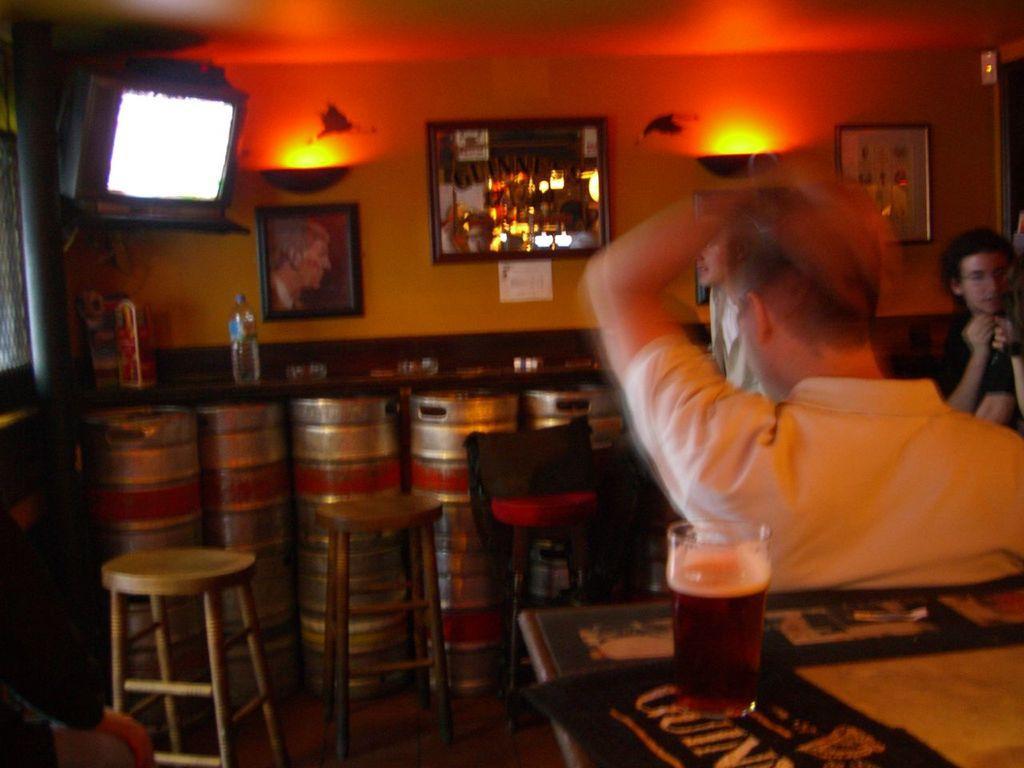Please provide a concise description of this image. This picture is a man and their some bottle kept on the table 